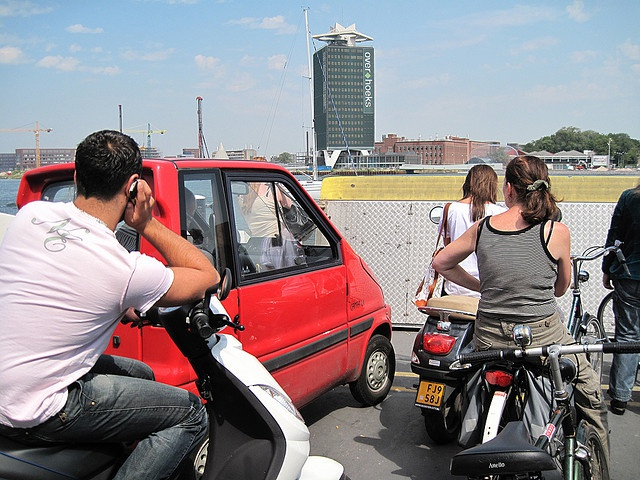Describe the objects in this image and their specific colors. I can see people in lightblue, lavender, black, gray, and darkgray tones, car in lightblue, red, black, salmon, and gray tones, people in lightblue, gray, black, darkgray, and tan tones, motorcycle in lightblue, black, white, gray, and darkgray tones, and bicycle in lightblue, black, gray, darkgray, and white tones in this image. 